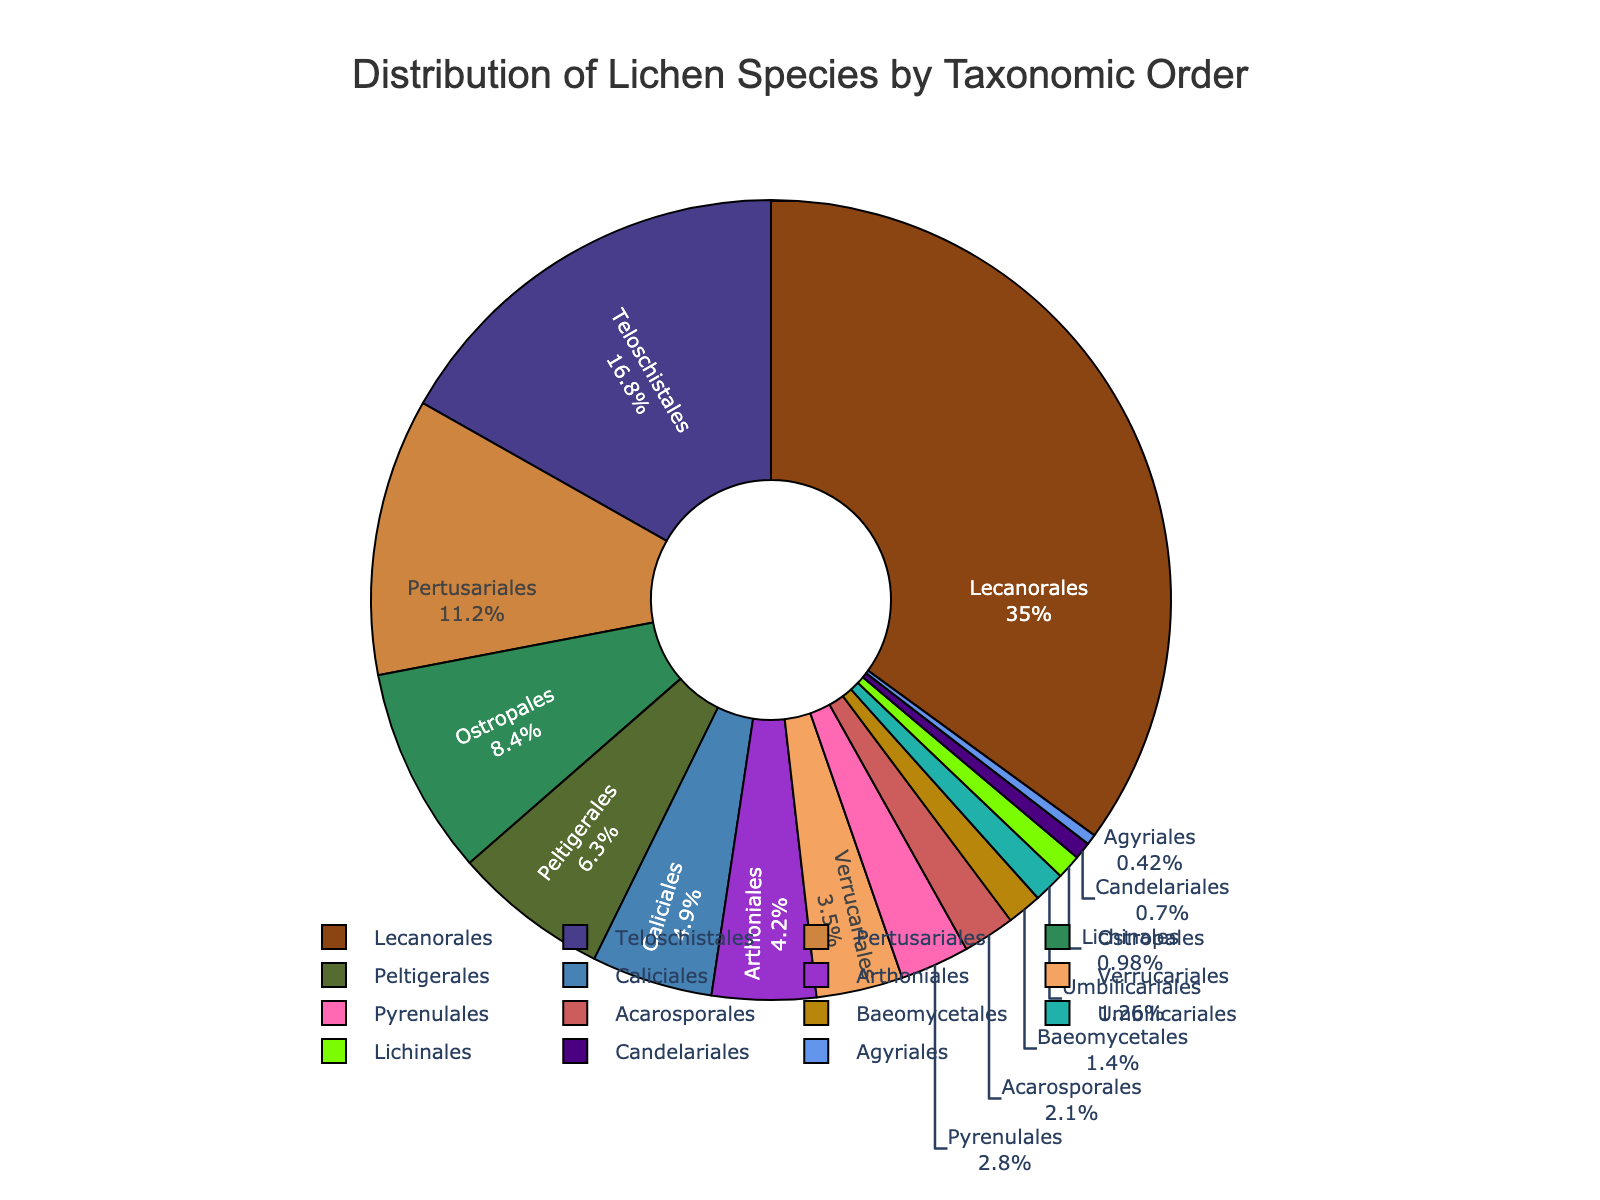How many times more species does Lecanorales have compared to Arthoniales? To find this, divide the number of species in Lecanorales by those in Arthoniales. Lecanorales has 2500 species and Arthoniales has 300 species. The calculation is 2500 / 300 ≈ 8.33
Answer: 8.33 Which two orders have the closest number of species counts? To determine this, compare the species counts for all orders. The closest counts are 90 for Umbilicariales and 100 for Baeomycetales, having a difference of only 10 species.
Answer: Umbilicariales and Baeomycetales What's the total percentage of species in the three orders with the highest species counts? Identify the top three orders: Lecanorales (2500), Teloschistales (1200), and Pertusariales (800). Sum their counts (2500 + 1200 + 800 = 4500). Then, calculate their combined percentage of the total (2500+450+1200+350+800+600+300+100+150+50+90+200+250+30+70 = 8140). The percentage is (4500 / 8140) * 100 ≈ 55.3%
Answer: 55.3% Which order has the smallest number of species, and what percentage does it represent? Identify the order with the smallest species count, which is Agyriales with 30 species. Calculate its percentage (30 / 8140) * 100 ≈ 0.37%
Answer: Agyriales, 0.37% How many species are there in orders that have fewer than 200 species each? Sum the species counts for orders with fewer than 200 species: Baeomycetales (100), Candelariales (50), Umbilicariales (90), Agyriales (30), Lichinales (70). The total is 100 + 50 + 90 + 30 + 70 = 340
Answer: 340 Which order has the second smallest number of species, and what color represents it? The second smallest number of species is in Candelariales with 50 species. According to the data and code provided, the color representing Candelariales is ‘golden’.
Answer: Candelariales, golden Calculate the difference in species counts between the orders with the most and the least species. The order with the most species is Lecanorales (2500), and the least is Agyriales (30). The difference is 2500 - 30 = 2470
Answer: 2470 What percentage of the total does the combination of Ostropales and Arthoniales represent? Combine the species counts for Ostropales (600) and Arthoniales (300), which totals 900. Then, calculate the percentage (900 / 8140) * 100 ≈ 11.06%
Answer: 11.06% Which two orders have equal species counts, and what is the number of species in each? Compare the species counts: Teloschistales and Pertusariales both have 1200 species.
Answer: Teloschistales and Pertusariales, 1200 What's the combined species count of the orders represented with shades of green and brown? Identify the orders: Peltigerales (450, green), Baeomycetales (100, brown), Umbilicariales (90, brown), Lichinales (70, green). Sum their counts: 450 + 100 + 90 + 70 = 710
Answer: 710 